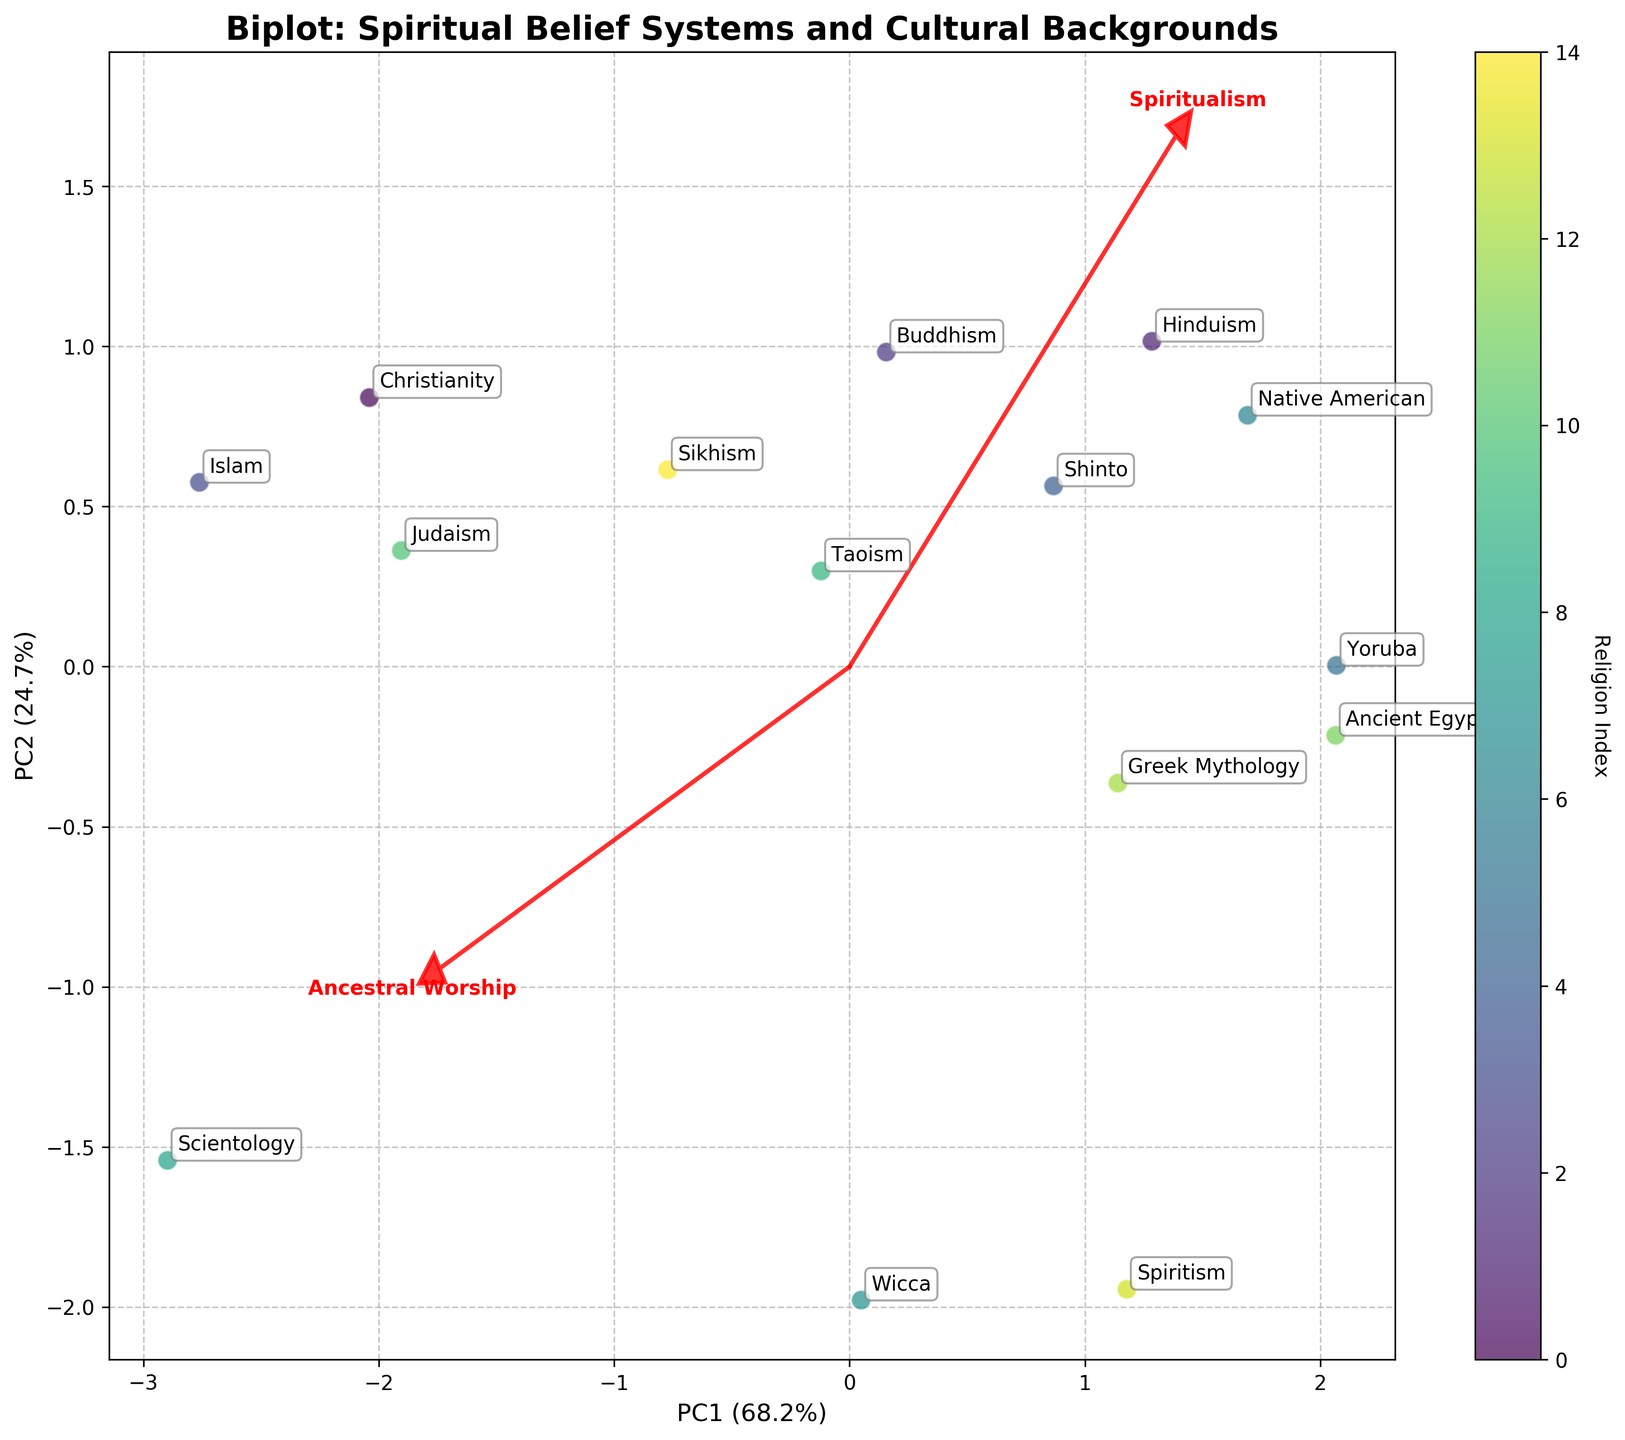What's the title of the biplot? The biplot's title is at the top of the figure in bold text. The title reads: "Biplot: Spiritual Belief Systems and Cultural Backgrounds".
Answer: Biplot: Spiritual Belief Systems and Cultural Backgrounds What are the labels of the axes in the biplot? The labels of the axes are located along the x-axis and y-axis of the biplot. They read: 'PC1' and 'PC2', followed by the percentage of variance explained.
Answer: PC1, PC2 How many different religions are depicted in the biplot? Each point in the biplot represents a different religion. There are 15 different data points plotted in the biplot, each annotated with a different religion name.
Answer: 15 Which feature vector has the greatest length and what does it indicate? The length of a feature vector in a biplot indicates the strength of that feature's contribution. The 'Reincarnation Belief' vector appears to be the longest, indicating it has a strong influence on the data's variation.
Answer: Reincarnation Belief Which religions are positioned closest to the 'Spiritualism' feature vector? Religions closest to the 'Spiritualism' feature vector will align more with high Spiritualism values. 'Wicca' and 'Spiritism' appear nearest to this vector.
Answer: Wicca, Spiritism Are 'Christianity' and 'Islam' positioned close to each other in the biplot? Observing the plot, both 'Christianity' and 'Islam' are placed close to each other, indicating they share similar values in the considered features.
Answer: Yes Which religion has the highest value on PC1? The positioning along the PC1 (x-axis) indicates values on this component. 'Spiritism' seems to have the highest value on PC1.
Answer: Spiritism Which religions are closest to the origin, and what could this imply? Religions close to the origin have values across the features that are very average. 'Christianity' and 'Islam' are among the religions closest to the origin.
Answer: Christianity, Islam Which two religions are farthest apart in the biplot, indicating the most different belief systems? Two religions that are farthest apart would represent the most varied belief systems in terms of the features. 'Christianity' and 'Ancient Egyptian' appear to be among the farthest apart.
Answer: Christianity, Ancient Egyptian 